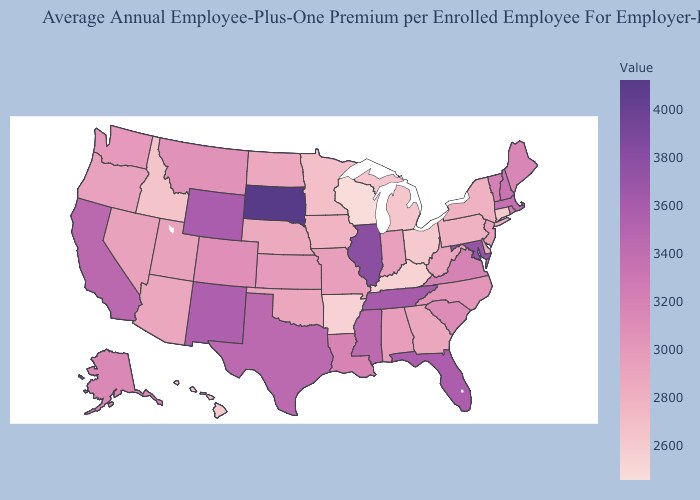Among the states that border Indiana , which have the lowest value?
Keep it brief. Kentucky. Among the states that border Arizona , which have the lowest value?
Be succinct. Nevada. Among the states that border Maine , which have the lowest value?
Keep it brief. New Hampshire. Does Tennessee have the highest value in the South?
Concise answer only. No. 